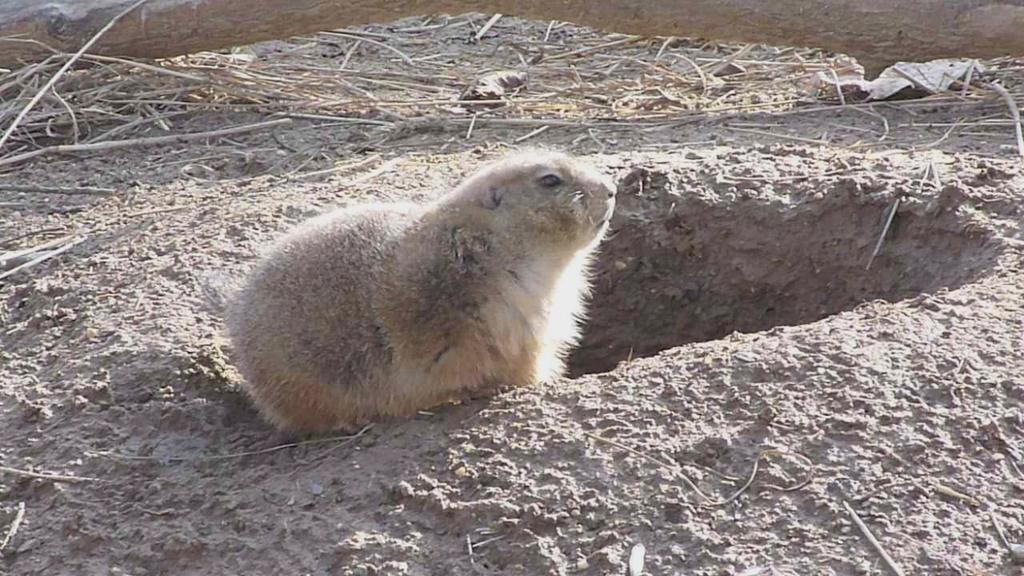What type of animal can be seen in the image? There is a cream-colored animal in the image. What else is present on the ground in the image? There are sticks on the ground in the image. What type of locket is the animal wearing in the image? There is no locket visible in the image, as the animal is not wearing any accessories. 